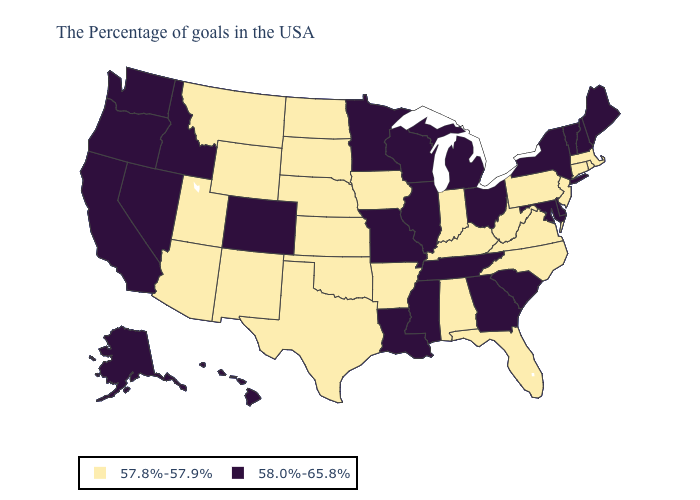What is the highest value in states that border Wisconsin?
Be succinct. 58.0%-65.8%. Which states have the highest value in the USA?
Answer briefly. Maine, New Hampshire, Vermont, New York, Delaware, Maryland, South Carolina, Ohio, Georgia, Michigan, Tennessee, Wisconsin, Illinois, Mississippi, Louisiana, Missouri, Minnesota, Colorado, Idaho, Nevada, California, Washington, Oregon, Alaska, Hawaii. Among the states that border Nevada , which have the lowest value?
Concise answer only. Utah, Arizona. Which states have the highest value in the USA?
Short answer required. Maine, New Hampshire, Vermont, New York, Delaware, Maryland, South Carolina, Ohio, Georgia, Michigan, Tennessee, Wisconsin, Illinois, Mississippi, Louisiana, Missouri, Minnesota, Colorado, Idaho, Nevada, California, Washington, Oregon, Alaska, Hawaii. Does Wyoming have a lower value than Nebraska?
Concise answer only. No. Which states have the highest value in the USA?
Short answer required. Maine, New Hampshire, Vermont, New York, Delaware, Maryland, South Carolina, Ohio, Georgia, Michigan, Tennessee, Wisconsin, Illinois, Mississippi, Louisiana, Missouri, Minnesota, Colorado, Idaho, Nevada, California, Washington, Oregon, Alaska, Hawaii. What is the highest value in states that border Maine?
Answer briefly. 58.0%-65.8%. What is the value of Michigan?
Quick response, please. 58.0%-65.8%. Does Minnesota have a higher value than Kentucky?
Answer briefly. Yes. What is the value of Oklahoma?
Write a very short answer. 57.8%-57.9%. What is the value of Mississippi?
Answer briefly. 58.0%-65.8%. What is the lowest value in states that border New Hampshire?
Keep it brief. 57.8%-57.9%. Name the states that have a value in the range 58.0%-65.8%?
Answer briefly. Maine, New Hampshire, Vermont, New York, Delaware, Maryland, South Carolina, Ohio, Georgia, Michigan, Tennessee, Wisconsin, Illinois, Mississippi, Louisiana, Missouri, Minnesota, Colorado, Idaho, Nevada, California, Washington, Oregon, Alaska, Hawaii. Which states hav the highest value in the South?
Give a very brief answer. Delaware, Maryland, South Carolina, Georgia, Tennessee, Mississippi, Louisiana. 